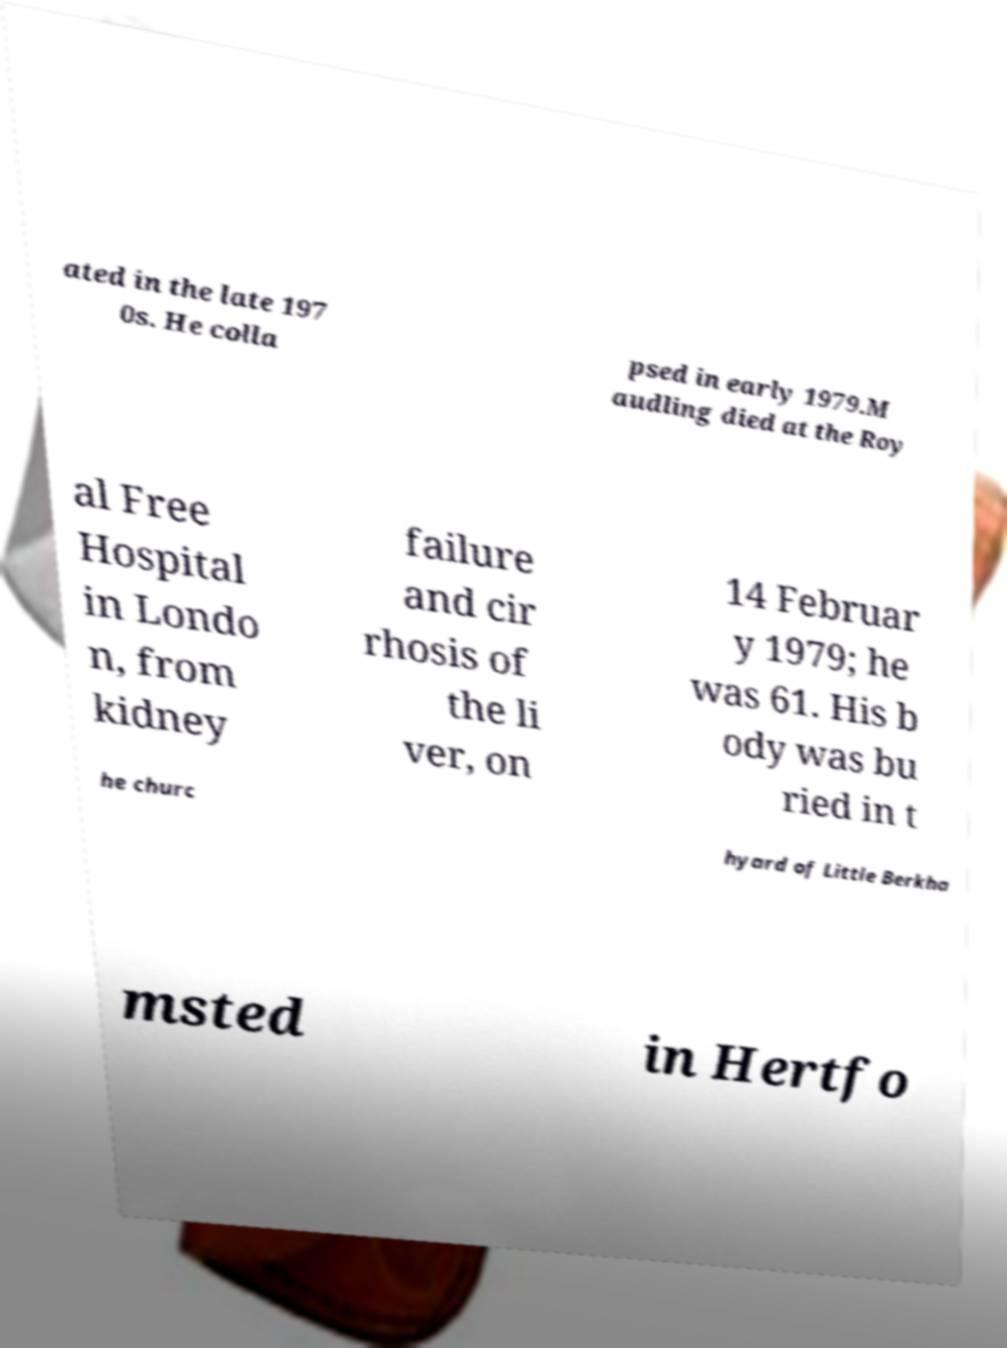Could you extract and type out the text from this image? ated in the late 197 0s. He colla psed in early 1979.M audling died at the Roy al Free Hospital in Londo n, from kidney failure and cir rhosis of the li ver, on 14 Februar y 1979; he was 61. His b ody was bu ried in t he churc hyard of Little Berkha msted in Hertfo 